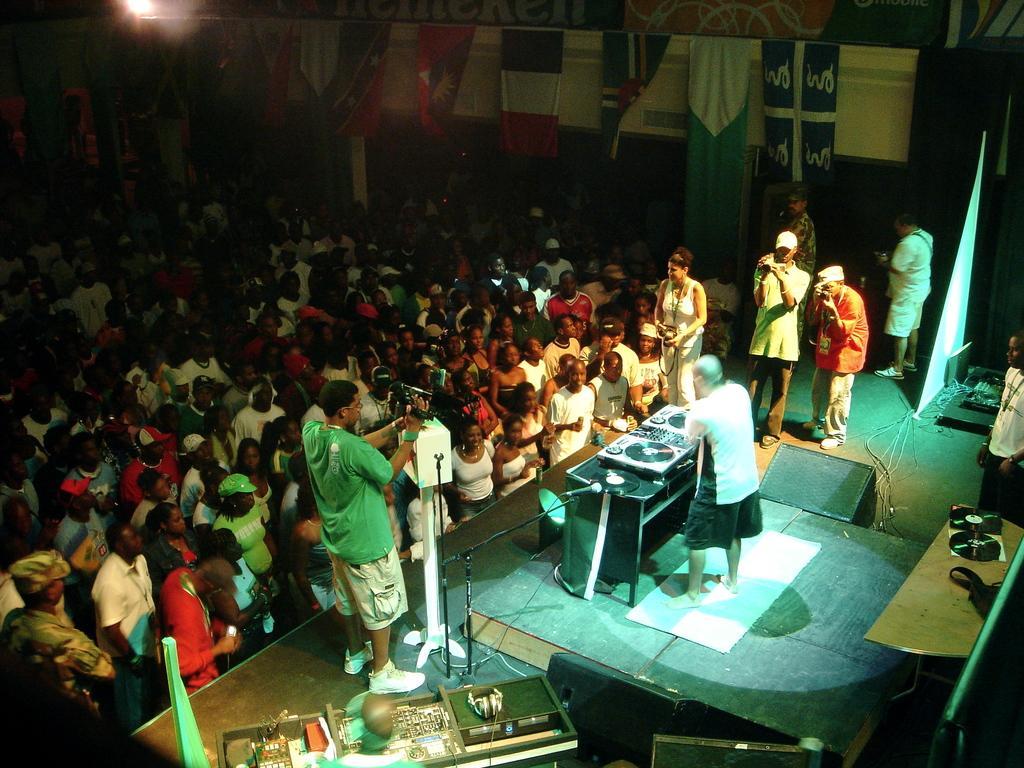Please provide a concise description of this image. There are many people in this room. Here on the stage,a person is playing DJ,around him people are taking his video and photographs. On the wall we can see flags,banner and a light. 